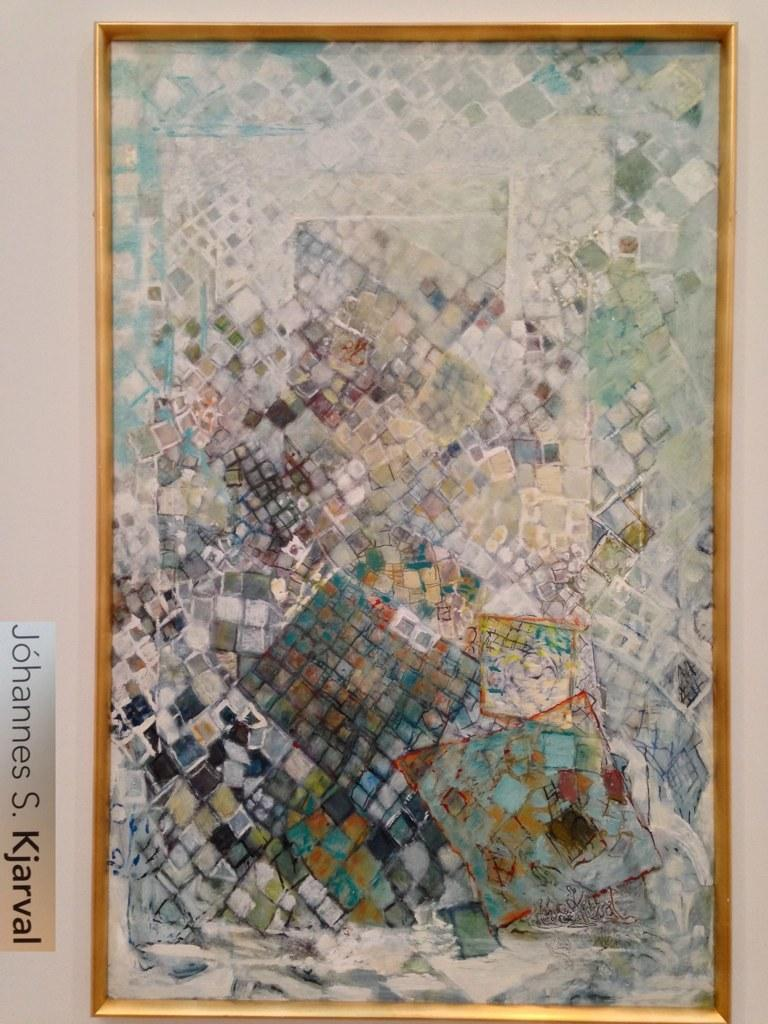Provide a one-sentence caption for the provided image. A colorful artwork that has been created by Johanes S. Kjarval. 